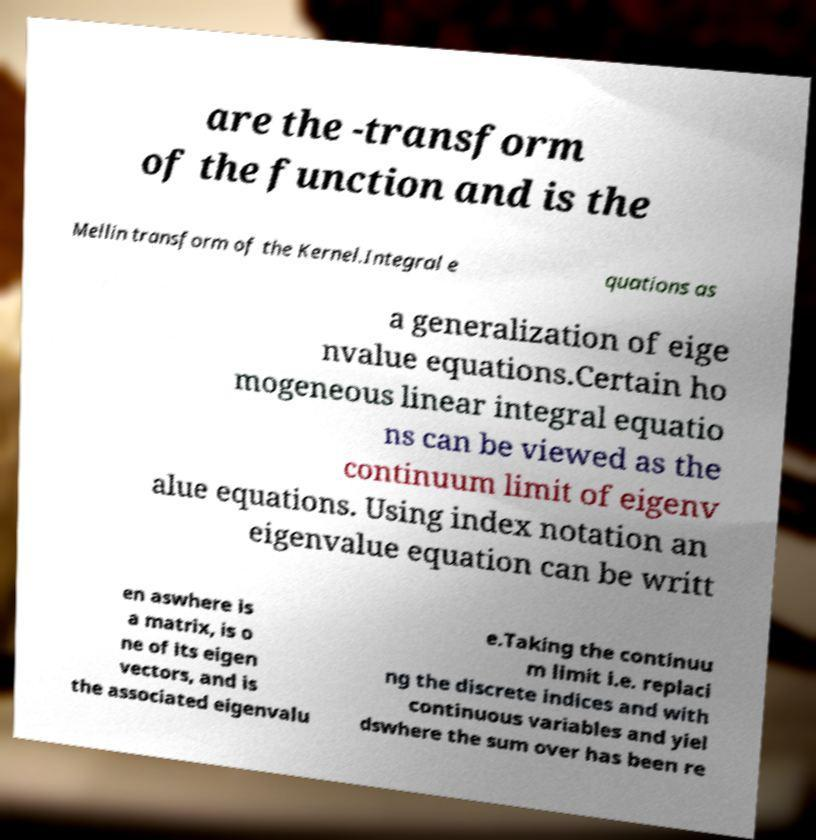I need the written content from this picture converted into text. Can you do that? are the -transform of the function and is the Mellin transform of the Kernel.Integral e quations as a generalization of eige nvalue equations.Certain ho mogeneous linear integral equatio ns can be viewed as the continuum limit of eigenv alue equations. Using index notation an eigenvalue equation can be writt en aswhere is a matrix, is o ne of its eigen vectors, and is the associated eigenvalu e.Taking the continuu m limit i.e. replaci ng the discrete indices and with continuous variables and yiel dswhere the sum over has been re 